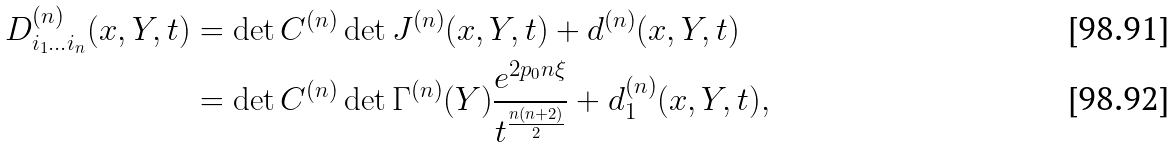<formula> <loc_0><loc_0><loc_500><loc_500>D ^ { ( n ) } _ { i _ { 1 } \dots i _ { n } } ( x , Y , t ) & = \det C ^ { ( n ) } \det J ^ { ( n ) } ( x , Y , t ) + d ^ { ( n ) } ( x , Y , t ) \\ & = \det C ^ { ( n ) } \det \Gamma ^ { ( n ) } ( Y ) \frac { e ^ { 2 p _ { 0 } n \xi } } { t ^ { \frac { n ( n + 2 ) } { 2 } } } + d _ { 1 } ^ { ( n ) } ( x , Y , t ) ,</formula> 